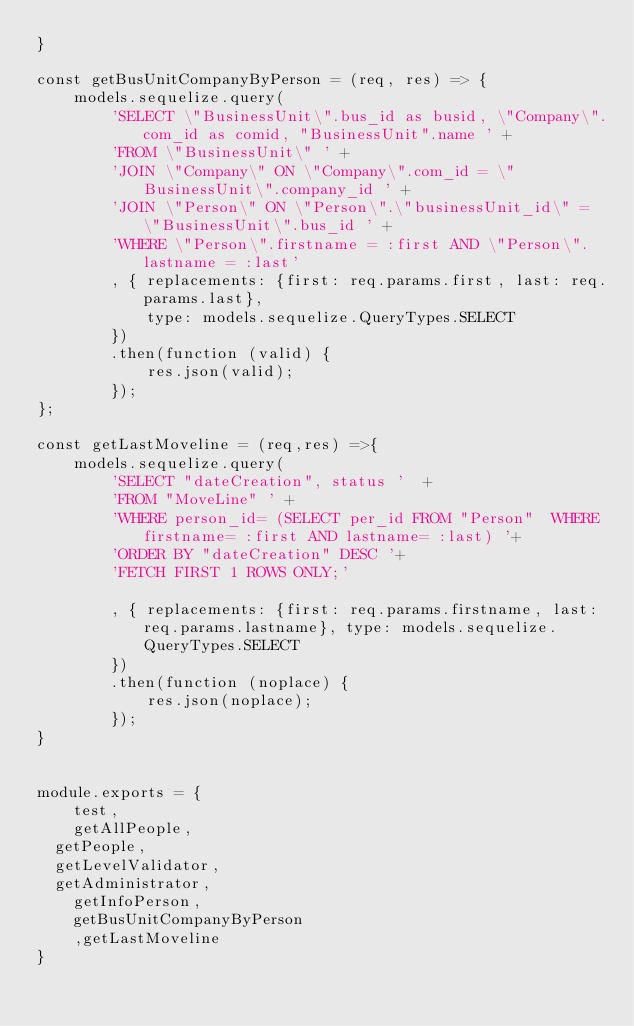<code> <loc_0><loc_0><loc_500><loc_500><_JavaScript_>}

const getBusUnitCompanyByPerson = (req, res) => {
    models.sequelize.query(
        'SELECT \"BusinessUnit\".bus_id as busid, \"Company\".com_id as comid, "BusinessUnit".name ' + 
        'FROM \"BusinessUnit\" ' +
        'JOIN \"Company\" ON \"Company\".com_id = \"BusinessUnit\".company_id ' +
        'JOIN \"Person\" ON \"Person\".\"businessUnit_id\" = \"BusinessUnit\".bus_id ' +
        'WHERE \"Person\".firstname = :first AND \"Person\".lastname = :last'
        , { replacements: {first: req.params.first, last: req.params.last},
            type: models.sequelize.QueryTypes.SELECT
        })
        .then(function (valid) {
            res.json(valid);
        });
};

const getLastMoveline = (req,res) =>{
    models.sequelize.query(
        'SELECT "dateCreation", status '  +
        'FROM "MoveLine" ' +
        'WHERE person_id= (SELECT per_id FROM "Person"  WHERE firstname= :first AND lastname= :last) '+
        'ORDER BY "dateCreation" DESC '+
        'FETCH FIRST 1 ROWS ONLY;'
        
        , { replacements: {first: req.params.firstname, last:req.params.lastname}, type: models.sequelize.QueryTypes.SELECT
        })
        .then(function (noplace) {
            res.json(noplace);
        });
}


module.exports = {
    test,
    getAllPeople,
	getPeople,
	getLevelValidator,
	getAdministrator,
    getInfoPerson,
    getBusUnitCompanyByPerson
    ,getLastMoveline
}</code> 